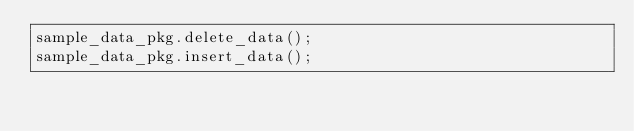Convert code to text. <code><loc_0><loc_0><loc_500><loc_500><_SQL_>sample_data_pkg.delete_data();
sample_data_pkg.insert_data();</code> 